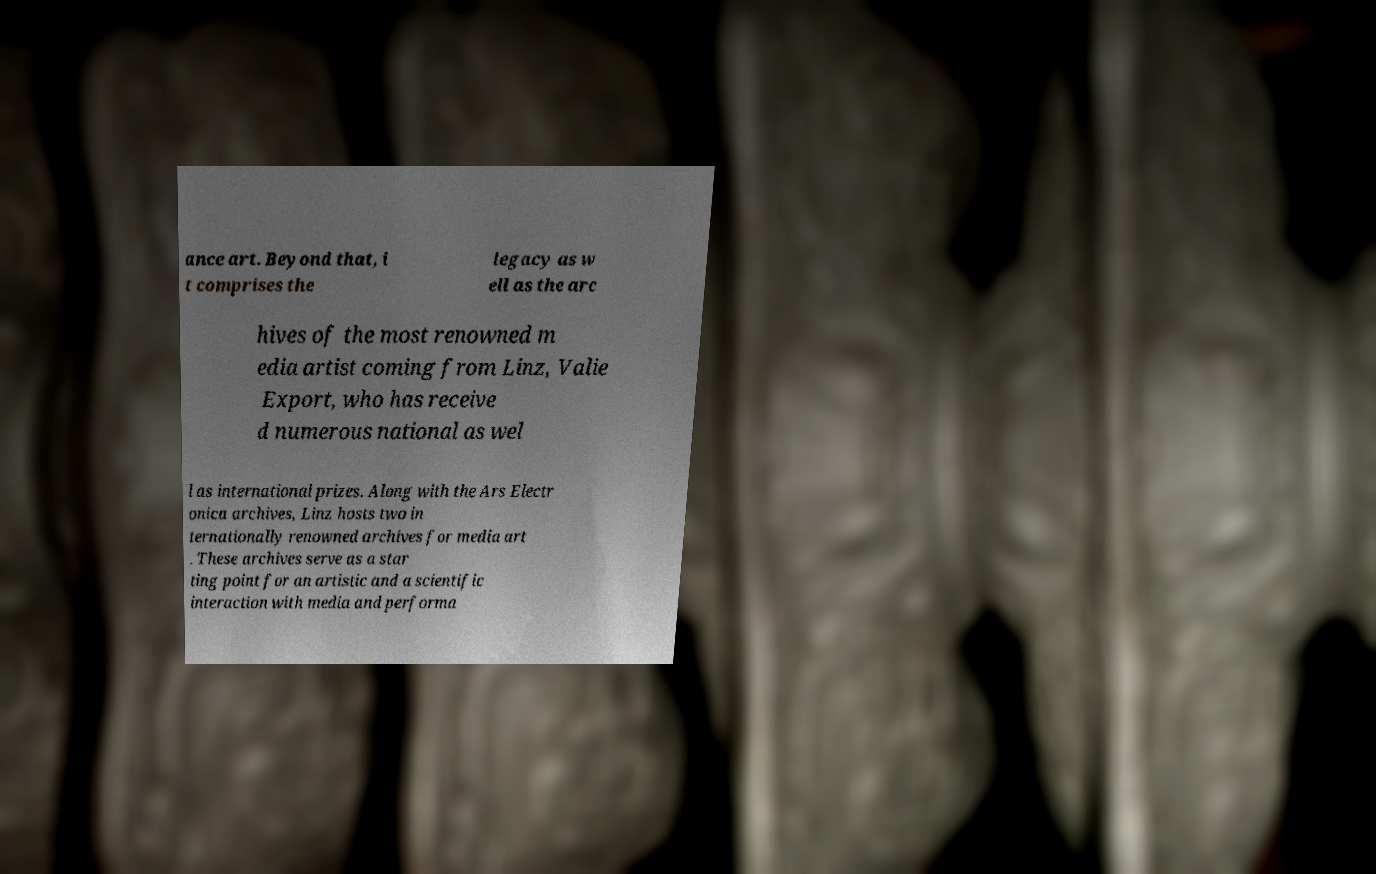Please identify and transcribe the text found in this image. ance art. Beyond that, i t comprises the legacy as w ell as the arc hives of the most renowned m edia artist coming from Linz, Valie Export, who has receive d numerous national as wel l as international prizes. Along with the Ars Electr onica archives, Linz hosts two in ternationally renowned archives for media art . These archives serve as a star ting point for an artistic and a scientific interaction with media and performa 